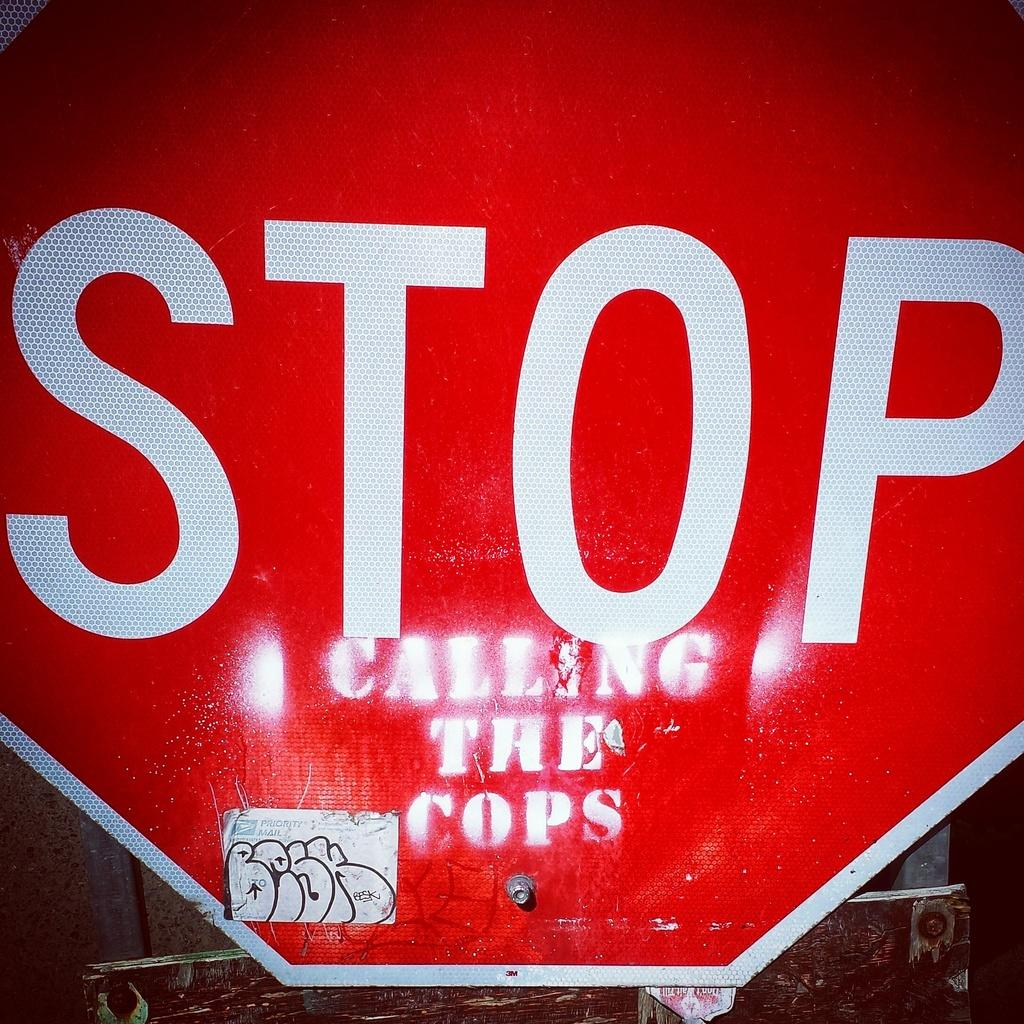<image>
Relay a brief, clear account of the picture shown. A close up of a top sign has graffiti added which says calling the cops 